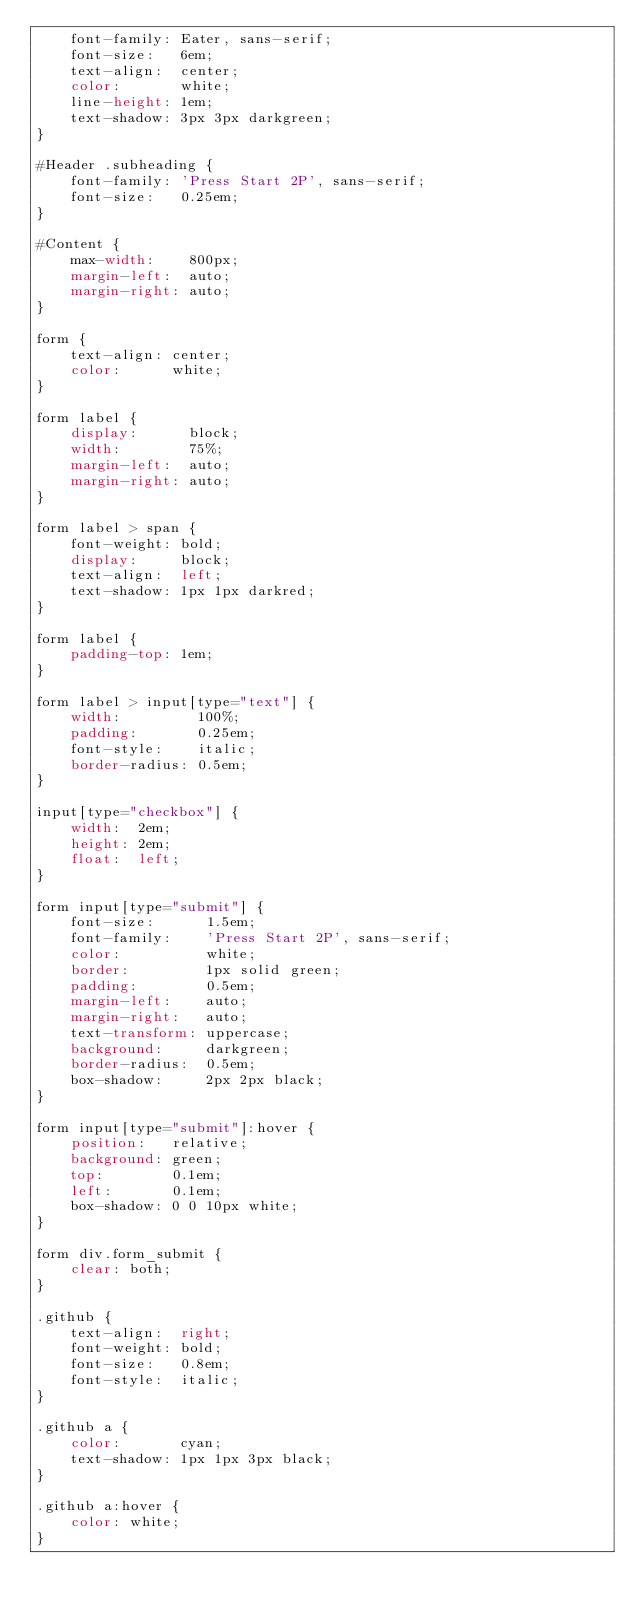<code> <loc_0><loc_0><loc_500><loc_500><_CSS_>    font-family: Eater, sans-serif;
    font-size:   6em;
    text-align:  center;
    color:       white;
    line-height: 1em;
    text-shadow: 3px 3px darkgreen;
}

#Header .subheading {
    font-family: 'Press Start 2P', sans-serif;
    font-size:   0.25em;
}

#Content {
    max-width:    800px;
    margin-left:  auto;
    margin-right: auto;
}

form {
    text-align: center;
    color:      white;
}

form label {
    display:      block;
    width:        75%;
    margin-left:  auto;
    margin-right: auto;
}

form label > span {
    font-weight: bold;
    display:     block;
    text-align:  left;
    text-shadow: 1px 1px darkred;
}

form label {
    padding-top: 1em;
}

form label > input[type="text"] {
    width:         100%;
    padding:       0.25em;
    font-style:    italic;
    border-radius: 0.5em;
}

input[type="checkbox"] {
    width:  2em;
    height: 2em;
    float:  left;
}

form input[type="submit"] {
    font-size:      1.5em;
    font-family:    'Press Start 2P', sans-serif;
    color:          white;
    border:         1px solid green;
    padding:        0.5em;
    margin-left:    auto;
    margin-right:   auto;
    text-transform: uppercase;
    background:     darkgreen;
    border-radius:  0.5em;
    box-shadow:     2px 2px black;
}

form input[type="submit"]:hover {
    position:   relative;
    background: green;
    top:        0.1em;
    left:       0.1em;
    box-shadow: 0 0 10px white;
}

form div.form_submit {
    clear: both;
}

.github {
    text-align:  right;
    font-weight: bold;
    font-size:   0.8em;
    font-style:  italic;
}

.github a {
    color:       cyan;
    text-shadow: 1px 1px 3px black;
}

.github a:hover {
    color: white;
}</code> 